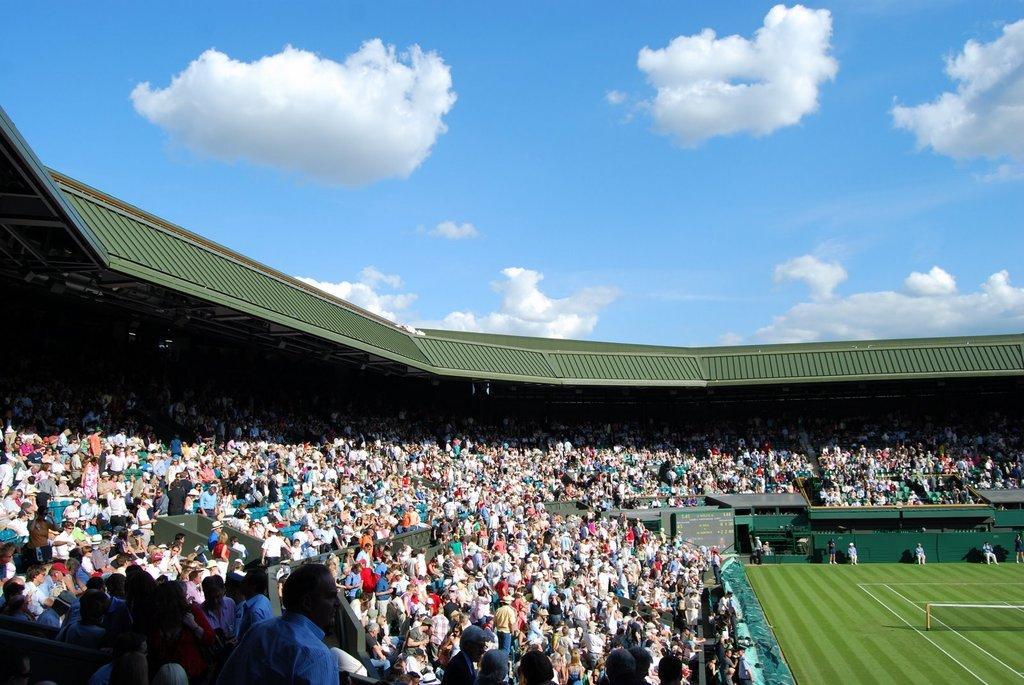Can you describe this image briefly? In this image, I can see groups of people sitting and standing in the stadium. In the bottom right corner of the image, I can see a ground with a sports net. I can see a board. In the background, there is the sky. 